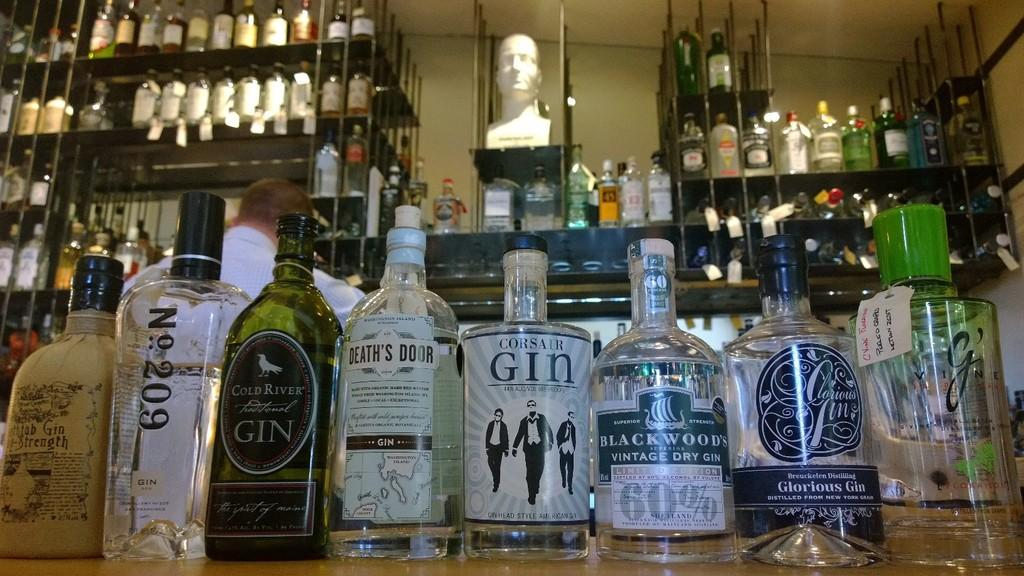<image>
Give a short and clear explanation of the subsequent image. Large assortment of primarily gin alcohol on shelves and racks 